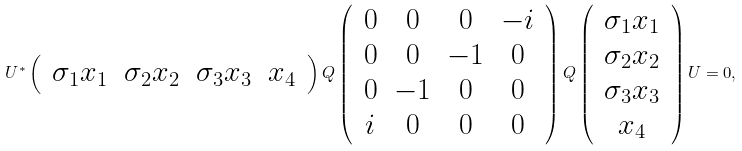<formula> <loc_0><loc_0><loc_500><loc_500>U ^ { * } \left ( \, \begin{array} { c c c c } \sigma _ { 1 } x _ { 1 } & \sigma _ { 2 } x _ { 2 } & \sigma _ { 3 } x _ { 3 } & x _ { 4 } \end{array} \, \right ) Q \left ( \, \begin{array} { c c c c } 0 & 0 & 0 & - i \\ 0 & 0 & - 1 & 0 \\ 0 & - 1 & 0 & 0 \\ i & 0 & 0 & 0 \end{array} \, \right ) Q \left ( \, \begin{array} { c } \sigma _ { 1 } x _ { 1 } \\ \sigma _ { 2 } x _ { 2 } \\ \sigma _ { 3 } x _ { 3 } \\ x _ { 4 } \end{array} \, \right ) U = 0 ,</formula> 